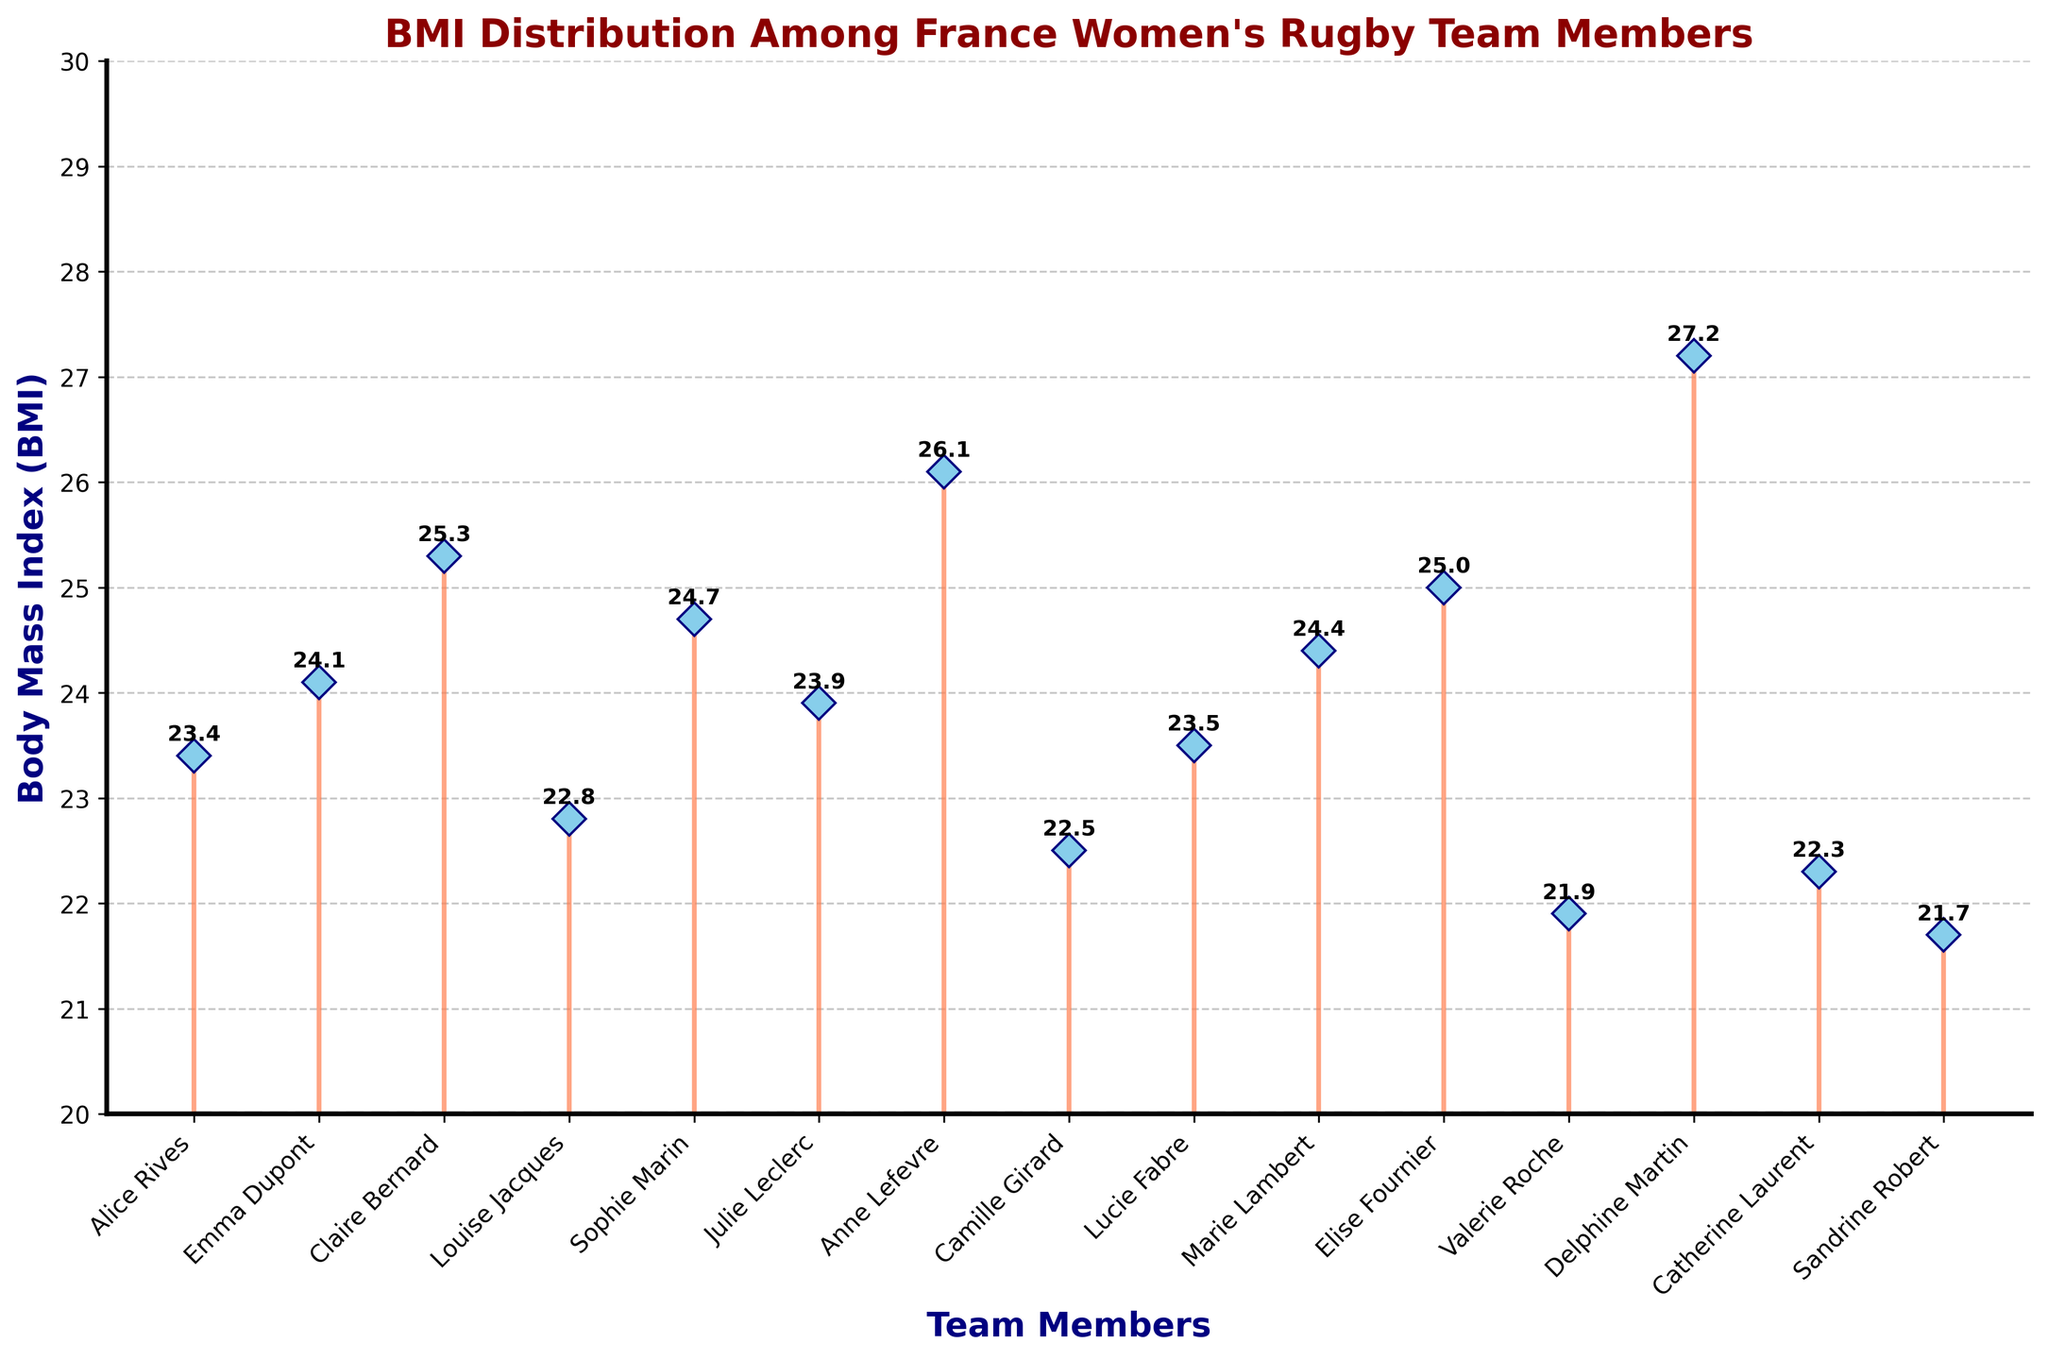What is the title of the plot? The title is usually found at the top of the plot and provides a summary of what the plot represents. Here, it states the main focus of the plot, which is BMI distribution among team members.
Answer: BMI Distribution Among France Women's Rugby Team Members What is the BMI of Alice Rives? To find Alice Rives' BMI, locate her name on the x-axis and find the corresponding value on the y-axis.
Answer: 23.4 How many team members have a BMI greater than 25? To determine this, count the number of data points (names) with BMI values on the y-axis greater than 25.
Answer: 3 What is the BMI range represented in the plot? The BMI range can be identified by looking at the minimum and maximum BMI values shown on the y-axis.
Answer: 21.7 to 27.2 Which team member has the lowest BMI, and what is it? To find this, visually scan the data points to see which one has the lowest position on the y-axis and identify the corresponding name and value.
Answer: Sandrine Robert, 21.7 Compare the BMI of Claire Bernard and Sophie Marin. Who has a higher BMI? To answer this, find Claire Bernard's and Sophie Marin's BMIs on the plot and compare their values.
Answer: Claire Bernard What is the median BMI of the team members? To find the median, list all individual BMIs in ascending order and determine the middle value. If the number of observations is even, average the two middle values.
Answer: 23.925 What's the difference between the highest and lowest BMI? First, find the highest BMI and the lowest BMI from the plot. Then subtract the lowest value from the highest value (27.2 - 21.7).
Answer: 5.5 What is the average BMI of the team members? Sum all the BMI values and divide by the number of team members (15). The total BMI sum is 351.5, so divide this by 15 (351.5 / 15).
Answer: 23.43 Which team members have a BMI between 24 and 25? Scan the plot to identify team members whose BMI values lie between 24 and 25 on the y-axis.
Answer: Emma Dupont, Sophie Marin, Marie Lambert, Elise Fournier 